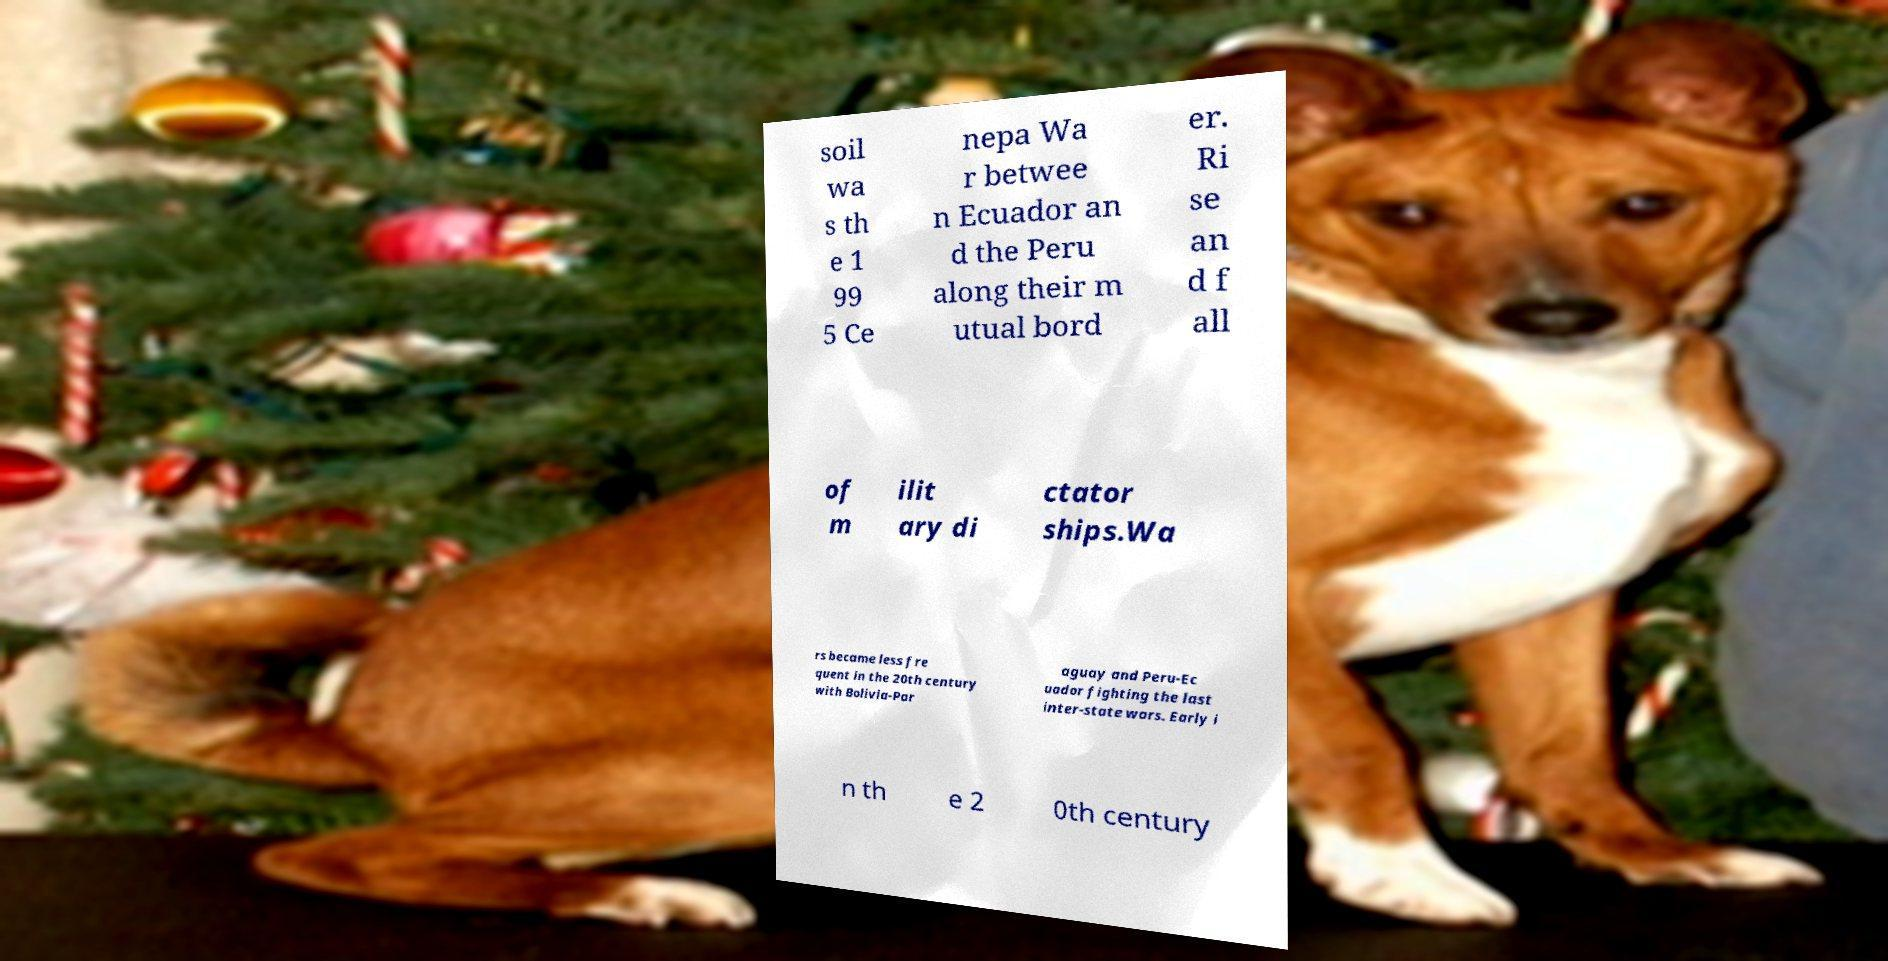Could you assist in decoding the text presented in this image and type it out clearly? soil wa s th e 1 99 5 Ce nepa Wa r betwee n Ecuador an d the Peru along their m utual bord er. Ri se an d f all of m ilit ary di ctator ships.Wa rs became less fre quent in the 20th century with Bolivia-Par aguay and Peru-Ec uador fighting the last inter-state wars. Early i n th e 2 0th century 